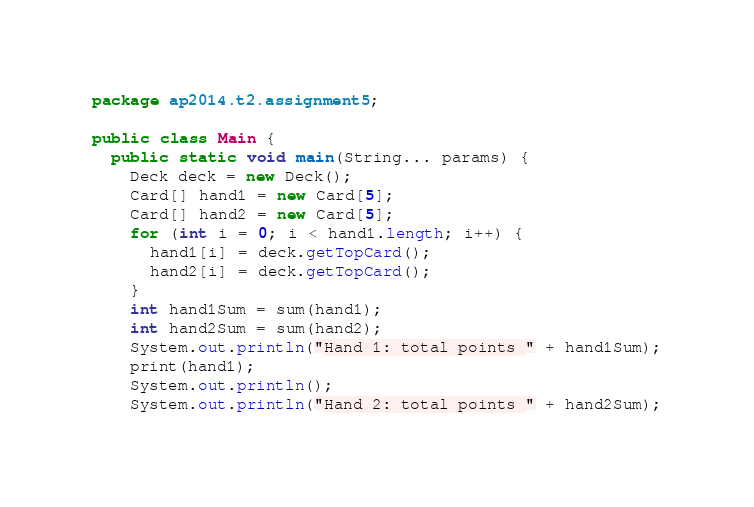<code> <loc_0><loc_0><loc_500><loc_500><_Java_>package ap2014.t2.assignment5;

public class Main {
  public static void main(String... params) {
    Deck deck = new Deck();
    Card[] hand1 = new Card[5];
    Card[] hand2 = new Card[5];
    for (int i = 0; i < hand1.length; i++) {
      hand1[i] = deck.getTopCard();
      hand2[i] = deck.getTopCard();
    }
    int hand1Sum = sum(hand1);
    int hand2Sum = sum(hand2);
    System.out.println("Hand 1: total points " + hand1Sum);
    print(hand1);
    System.out.println();
    System.out.println("Hand 2: total points " + hand2Sum);</code> 